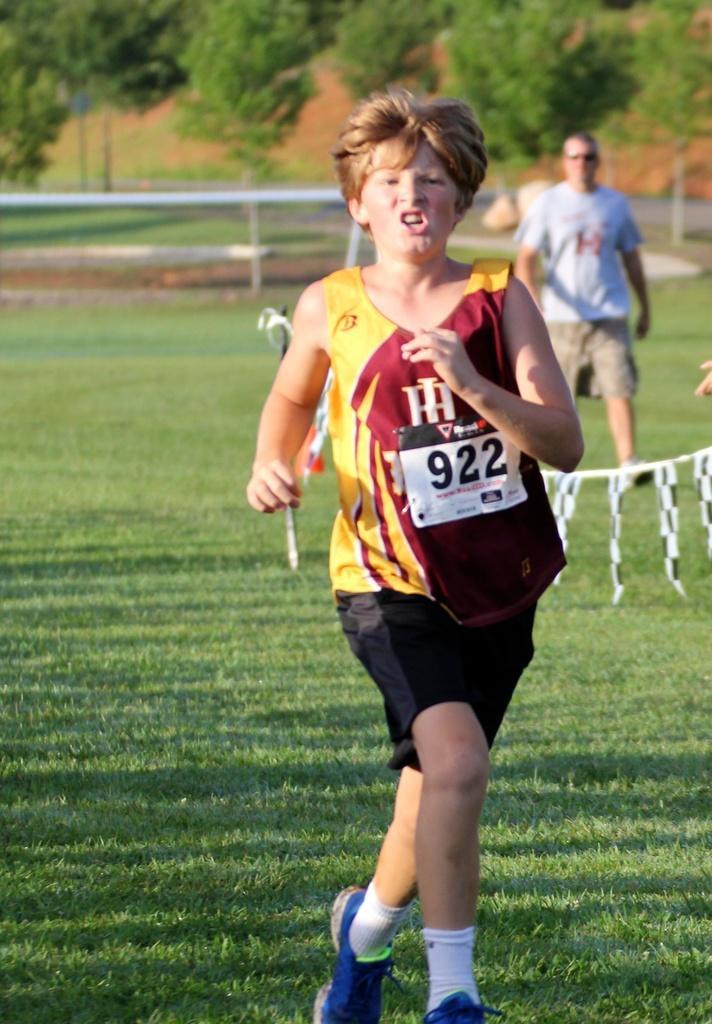Could you give a brief overview of what you see in this image? In the center of the image we can see a person is running. On the right side of the image we can see a man is walking and wearing goggles. In the background of the image we can see the trees, rods, grass. At the bottom of the image we can see the ground. 